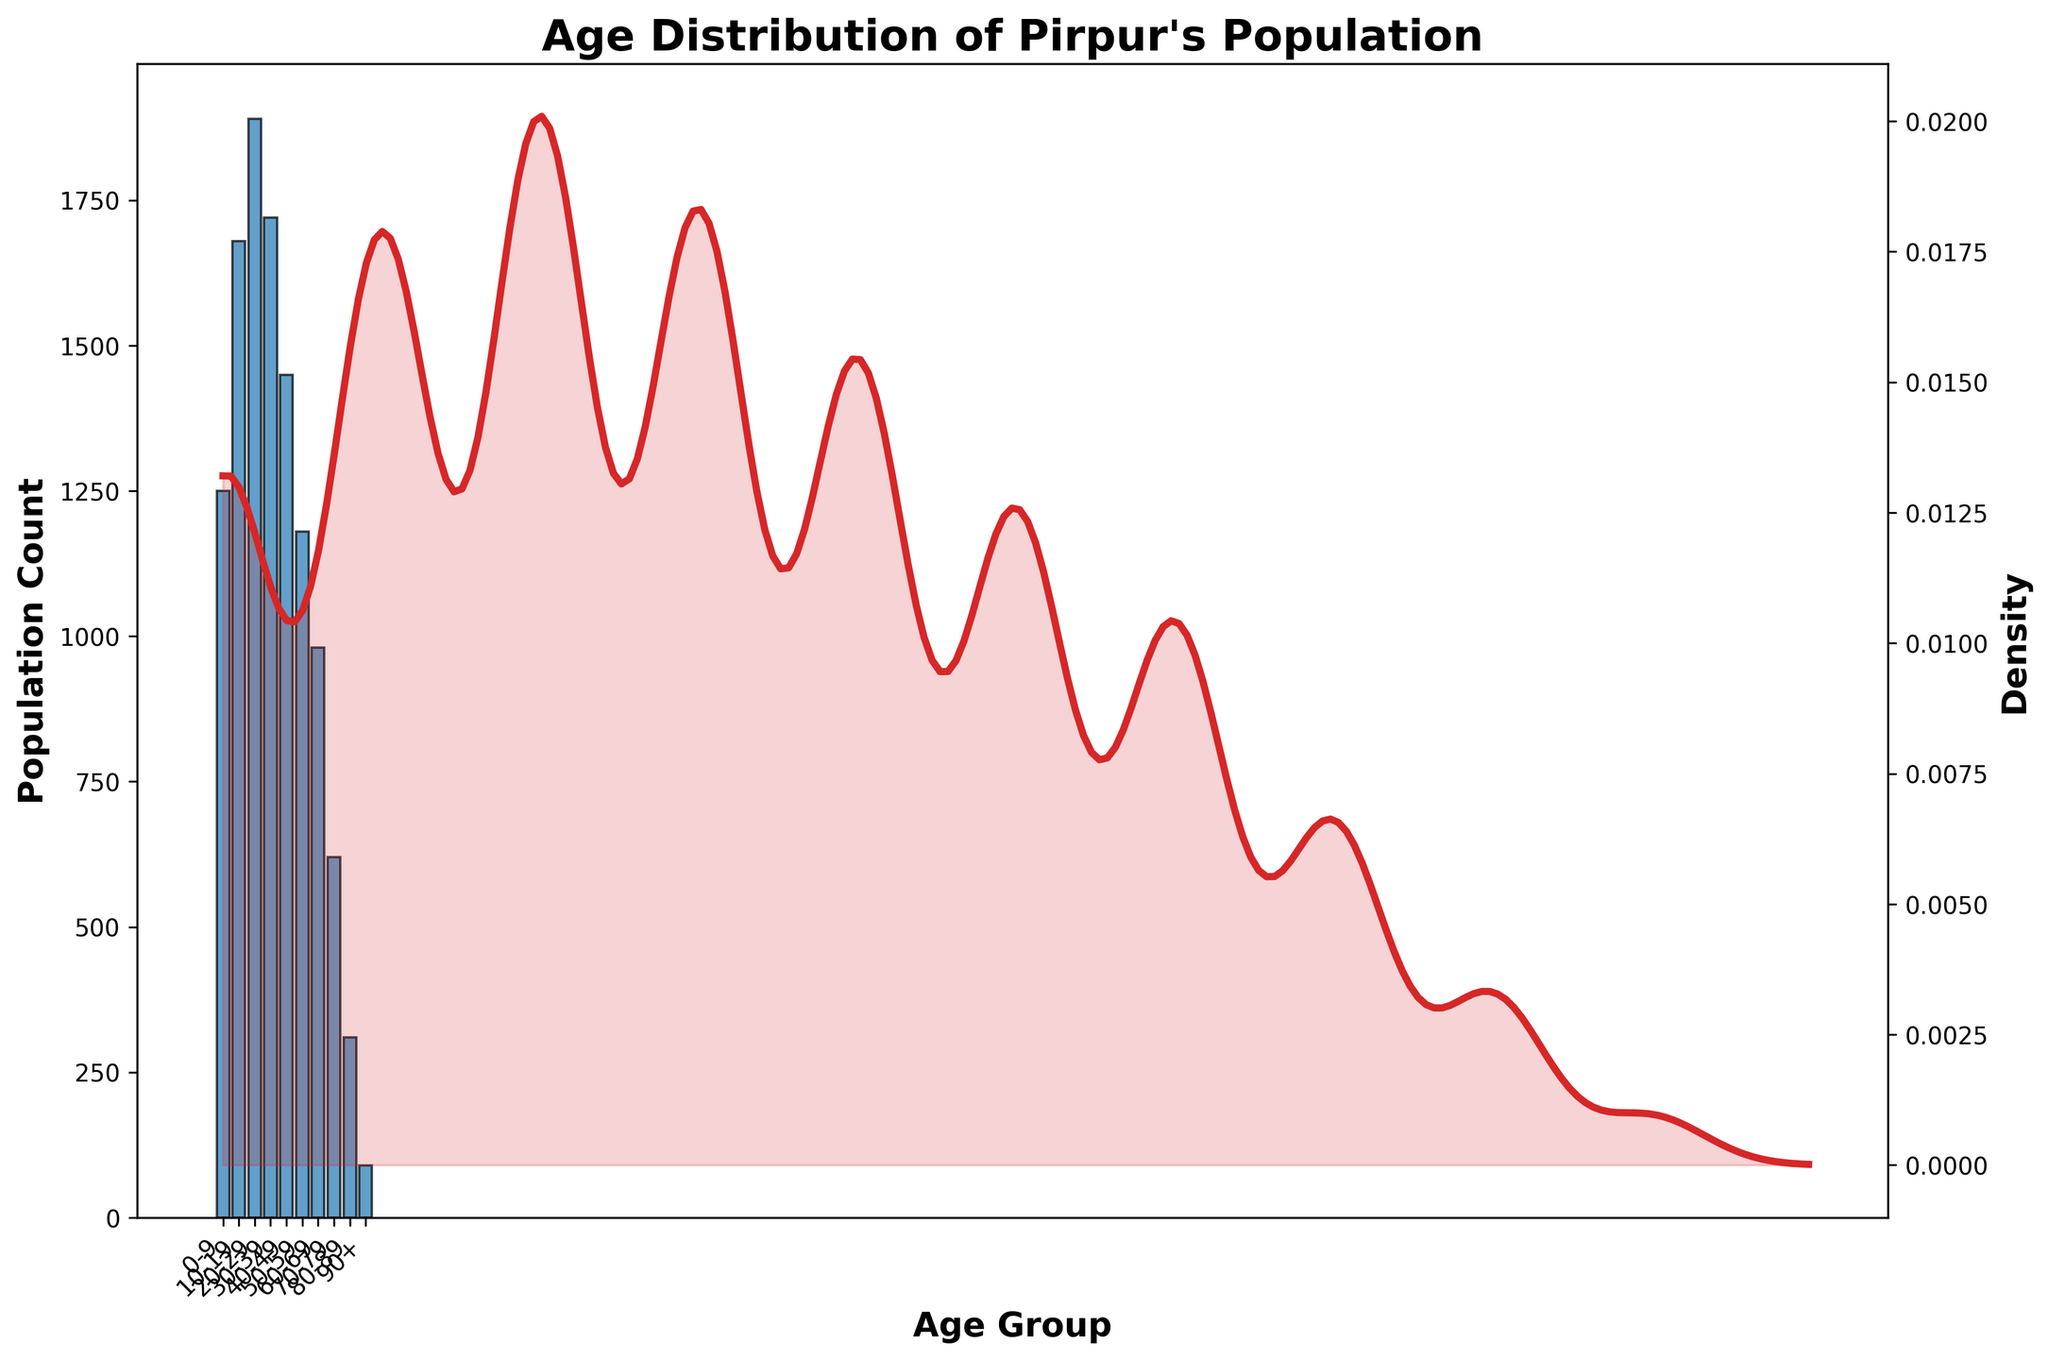What is the title of the figure? Look at the top of the figure to identify the title. The title is usually written in bold and larger font size.
Answer: Age Distribution of Pirpur's Population Which age group has the highest population count? Find the tallest bar in the histogram, which represents the age group with the highest count.
Answer: 20-29 How many people are in the 50-59 age group? Identify the bar corresponding to the 50-59 age group and look at its height to find the count.
Answer: 1180 Compare the population count of the 60-69 and 70-79 age groups. Which is higher? Look at the heights of the bars for the 60-69 and 70-79 age groups and compare them.
Answer: 60-69 What is the general trend of the population count as age increases? Observe the general pattern of the histogram bars. Note if the bars mostly increase, decrease, or fluctuate.
Answer: Decreases What is the approximate density value for the age group 40-49? Look at the KDE curve's height at the position corresponding to the age group 40-49.
Answer: Around 0.012 Calculate the sum of the population counts for ages 0-29. Add the counts of the age groups 0-9, 10-19, and 20-29. The counts are 1250 + 1680 + 1890.
Answer: 4820 What is the average population count of the age groups 40-49, 50-59, and 60-69? Calculate the mean by adding the counts of these age groups and then dividing by the number of groups: (1450 + 1180 + 980) / 3
Answer: 1203.33 Compare the density values of ages 20 and 50. Which is higher? Look at the heights of the KDE curve at ages 20 and 50 and compare them.
Answer: 20 Is there an age group where the density curve shows a significant decrease? If so, which one? Look for a steep drop in the KDE curve. Identify the corresponding age range.
Answer: 70-79 